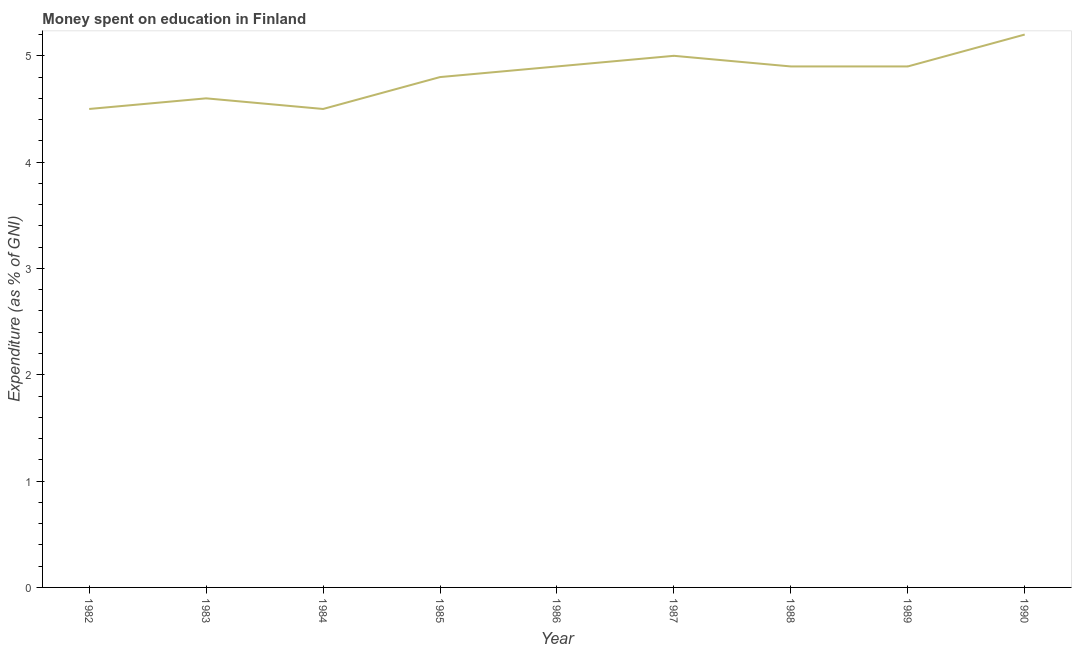What is the expenditure on education in 1986?
Make the answer very short. 4.9. Across all years, what is the maximum expenditure on education?
Offer a terse response. 5.2. What is the sum of the expenditure on education?
Make the answer very short. 43.3. What is the difference between the expenditure on education in 1988 and 1990?
Provide a short and direct response. -0.3. What is the average expenditure on education per year?
Your answer should be very brief. 4.81. Do a majority of the years between 1984 and 1988 (inclusive) have expenditure on education greater than 2.4 %?
Offer a terse response. Yes. What is the ratio of the expenditure on education in 1982 to that in 1983?
Ensure brevity in your answer.  0.98. What is the difference between the highest and the second highest expenditure on education?
Ensure brevity in your answer.  0.2. What is the difference between the highest and the lowest expenditure on education?
Ensure brevity in your answer.  0.7. In how many years, is the expenditure on education greater than the average expenditure on education taken over all years?
Your answer should be very brief. 5. Does the expenditure on education monotonically increase over the years?
Provide a short and direct response. No. How many years are there in the graph?
Offer a terse response. 9. What is the difference between two consecutive major ticks on the Y-axis?
Provide a short and direct response. 1. Does the graph contain any zero values?
Your answer should be very brief. No. Does the graph contain grids?
Provide a succinct answer. No. What is the title of the graph?
Keep it short and to the point. Money spent on education in Finland. What is the label or title of the X-axis?
Offer a very short reply. Year. What is the label or title of the Y-axis?
Your answer should be very brief. Expenditure (as % of GNI). What is the Expenditure (as % of GNI) of 1982?
Your answer should be compact. 4.5. What is the Expenditure (as % of GNI) in 1986?
Ensure brevity in your answer.  4.9. What is the Expenditure (as % of GNI) of 1987?
Make the answer very short. 5. What is the Expenditure (as % of GNI) in 1988?
Ensure brevity in your answer.  4.9. What is the difference between the Expenditure (as % of GNI) in 1982 and 1986?
Your answer should be compact. -0.4. What is the difference between the Expenditure (as % of GNI) in 1982 and 1988?
Make the answer very short. -0.4. What is the difference between the Expenditure (as % of GNI) in 1983 and 1984?
Provide a succinct answer. 0.1. What is the difference between the Expenditure (as % of GNI) in 1983 and 1987?
Provide a succinct answer. -0.4. What is the difference between the Expenditure (as % of GNI) in 1983 and 1989?
Provide a short and direct response. -0.3. What is the difference between the Expenditure (as % of GNI) in 1983 and 1990?
Your response must be concise. -0.6. What is the difference between the Expenditure (as % of GNI) in 1984 and 1985?
Offer a very short reply. -0.3. What is the difference between the Expenditure (as % of GNI) in 1984 and 1987?
Your answer should be very brief. -0.5. What is the difference between the Expenditure (as % of GNI) in 1984 and 1988?
Your answer should be very brief. -0.4. What is the difference between the Expenditure (as % of GNI) in 1985 and 1986?
Provide a short and direct response. -0.1. What is the difference between the Expenditure (as % of GNI) in 1985 and 1987?
Your answer should be compact. -0.2. What is the difference between the Expenditure (as % of GNI) in 1985 and 1990?
Make the answer very short. -0.4. What is the difference between the Expenditure (as % of GNI) in 1986 and 1987?
Provide a succinct answer. -0.1. What is the difference between the Expenditure (as % of GNI) in 1986 and 1988?
Ensure brevity in your answer.  0. What is the difference between the Expenditure (as % of GNI) in 1986 and 1989?
Your answer should be very brief. 0. What is the difference between the Expenditure (as % of GNI) in 1987 and 1990?
Provide a succinct answer. -0.2. What is the ratio of the Expenditure (as % of GNI) in 1982 to that in 1983?
Provide a succinct answer. 0.98. What is the ratio of the Expenditure (as % of GNI) in 1982 to that in 1984?
Offer a very short reply. 1. What is the ratio of the Expenditure (as % of GNI) in 1982 to that in 1985?
Keep it short and to the point. 0.94. What is the ratio of the Expenditure (as % of GNI) in 1982 to that in 1986?
Offer a terse response. 0.92. What is the ratio of the Expenditure (as % of GNI) in 1982 to that in 1988?
Provide a short and direct response. 0.92. What is the ratio of the Expenditure (as % of GNI) in 1982 to that in 1989?
Your response must be concise. 0.92. What is the ratio of the Expenditure (as % of GNI) in 1982 to that in 1990?
Give a very brief answer. 0.86. What is the ratio of the Expenditure (as % of GNI) in 1983 to that in 1985?
Give a very brief answer. 0.96. What is the ratio of the Expenditure (as % of GNI) in 1983 to that in 1986?
Make the answer very short. 0.94. What is the ratio of the Expenditure (as % of GNI) in 1983 to that in 1987?
Your answer should be compact. 0.92. What is the ratio of the Expenditure (as % of GNI) in 1983 to that in 1988?
Give a very brief answer. 0.94. What is the ratio of the Expenditure (as % of GNI) in 1983 to that in 1989?
Offer a terse response. 0.94. What is the ratio of the Expenditure (as % of GNI) in 1983 to that in 1990?
Ensure brevity in your answer.  0.89. What is the ratio of the Expenditure (as % of GNI) in 1984 to that in 1985?
Your answer should be very brief. 0.94. What is the ratio of the Expenditure (as % of GNI) in 1984 to that in 1986?
Keep it short and to the point. 0.92. What is the ratio of the Expenditure (as % of GNI) in 1984 to that in 1988?
Provide a short and direct response. 0.92. What is the ratio of the Expenditure (as % of GNI) in 1984 to that in 1989?
Your answer should be very brief. 0.92. What is the ratio of the Expenditure (as % of GNI) in 1984 to that in 1990?
Ensure brevity in your answer.  0.86. What is the ratio of the Expenditure (as % of GNI) in 1985 to that in 1990?
Your answer should be compact. 0.92. What is the ratio of the Expenditure (as % of GNI) in 1986 to that in 1988?
Offer a very short reply. 1. What is the ratio of the Expenditure (as % of GNI) in 1986 to that in 1990?
Offer a terse response. 0.94. What is the ratio of the Expenditure (as % of GNI) in 1988 to that in 1989?
Provide a short and direct response. 1. What is the ratio of the Expenditure (as % of GNI) in 1988 to that in 1990?
Offer a terse response. 0.94. What is the ratio of the Expenditure (as % of GNI) in 1989 to that in 1990?
Give a very brief answer. 0.94. 